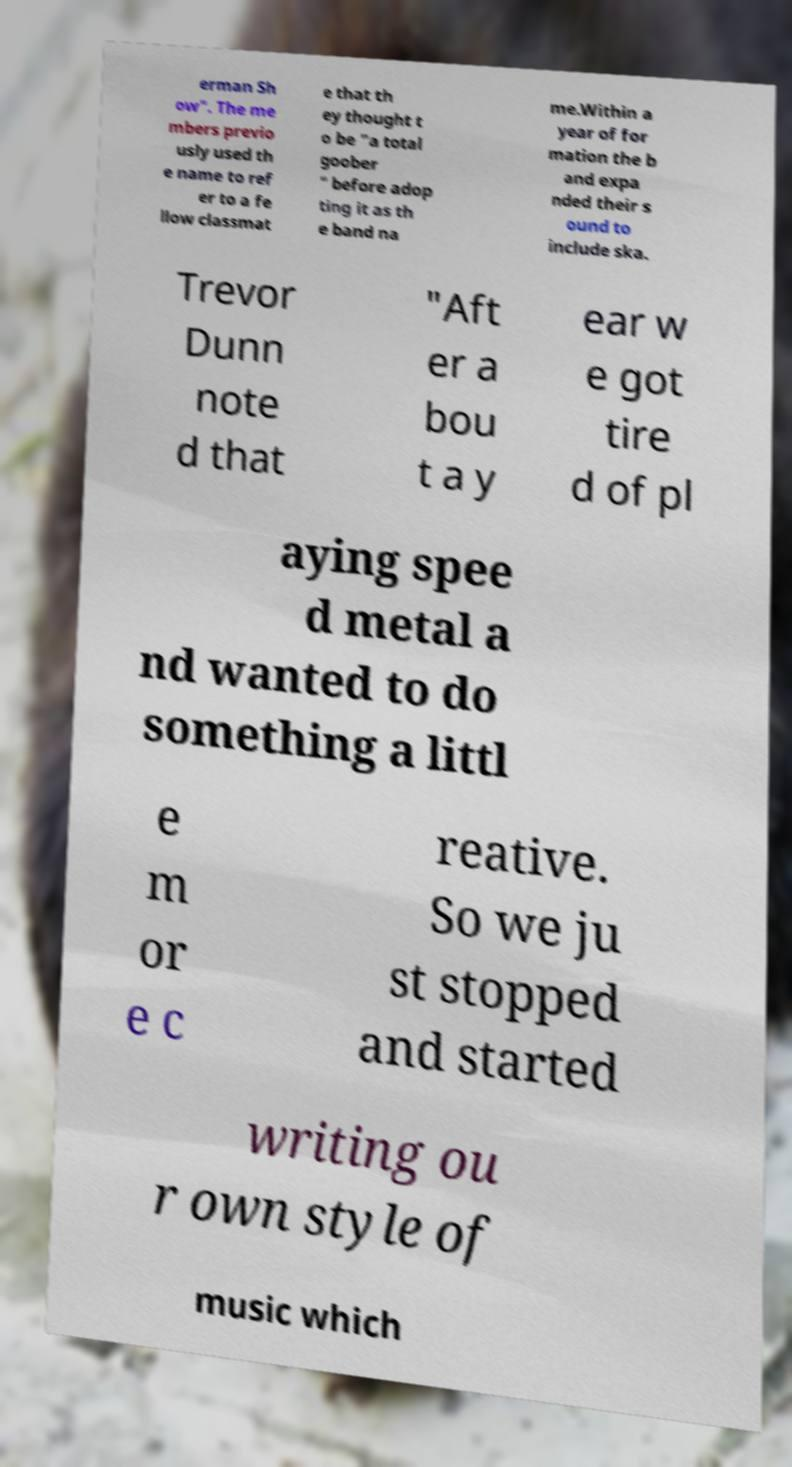For documentation purposes, I need the text within this image transcribed. Could you provide that? erman Sh ow". The me mbers previo usly used th e name to ref er to a fe llow classmat e that th ey thought t o be "a total goober " before adop ting it as th e band na me.Within a year of for mation the b and expa nded their s ound to include ska. Trevor Dunn note d that "Aft er a bou t a y ear w e got tire d of pl aying spee d metal a nd wanted to do something a littl e m or e c reative. So we ju st stopped and started writing ou r own style of music which 